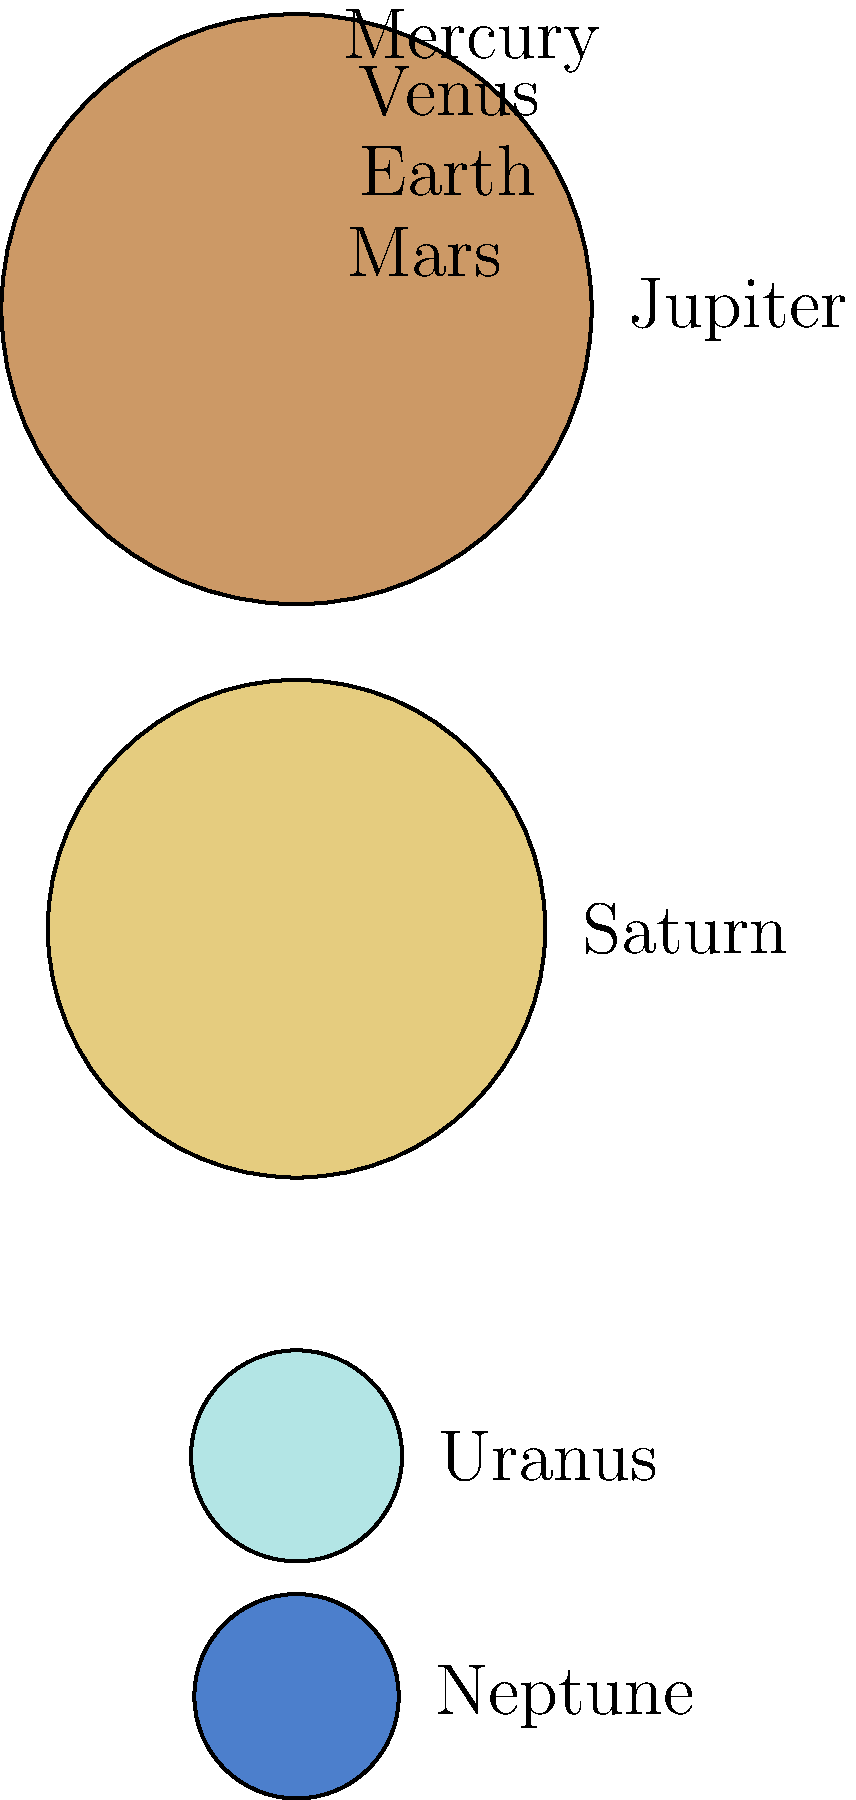As a digital media artist creating highlight reels for athletes, you often need to incorporate educational content. You're designing an infographic about the solar system to showcase an athlete's interest in astronomy. Which planet has a diameter closest to twice that of Earth? Let's approach this step-by-step:

1. The circles in the image represent the relative sizes of the planets in our solar system.

2. We need to find a planet with a diameter close to twice that of Earth.

3. Earth's diameter is represented by a circle with radius 12.7 units.

4. To find a planet with twice Earth's diameter, we're looking for a circle with a radius close to $12.7 \times 2 = 25.4$ units.

5. Let's compare the radii of the larger planets to this value:
   - Jupiter: 142.9 (much larger)
   - Saturn: 120.5 (much larger)
   - Uranus: 51.1
   - Neptune: 49.5

6. Uranus (51.1) and Neptune (49.5) are the closest to our target of 25.4.

7. Between these two, Neptune's radius (49.5) is slightly closer to twice Earth's radius (25.4).

Therefore, Neptune has a diameter closest to twice that of Earth.
Answer: Neptune 